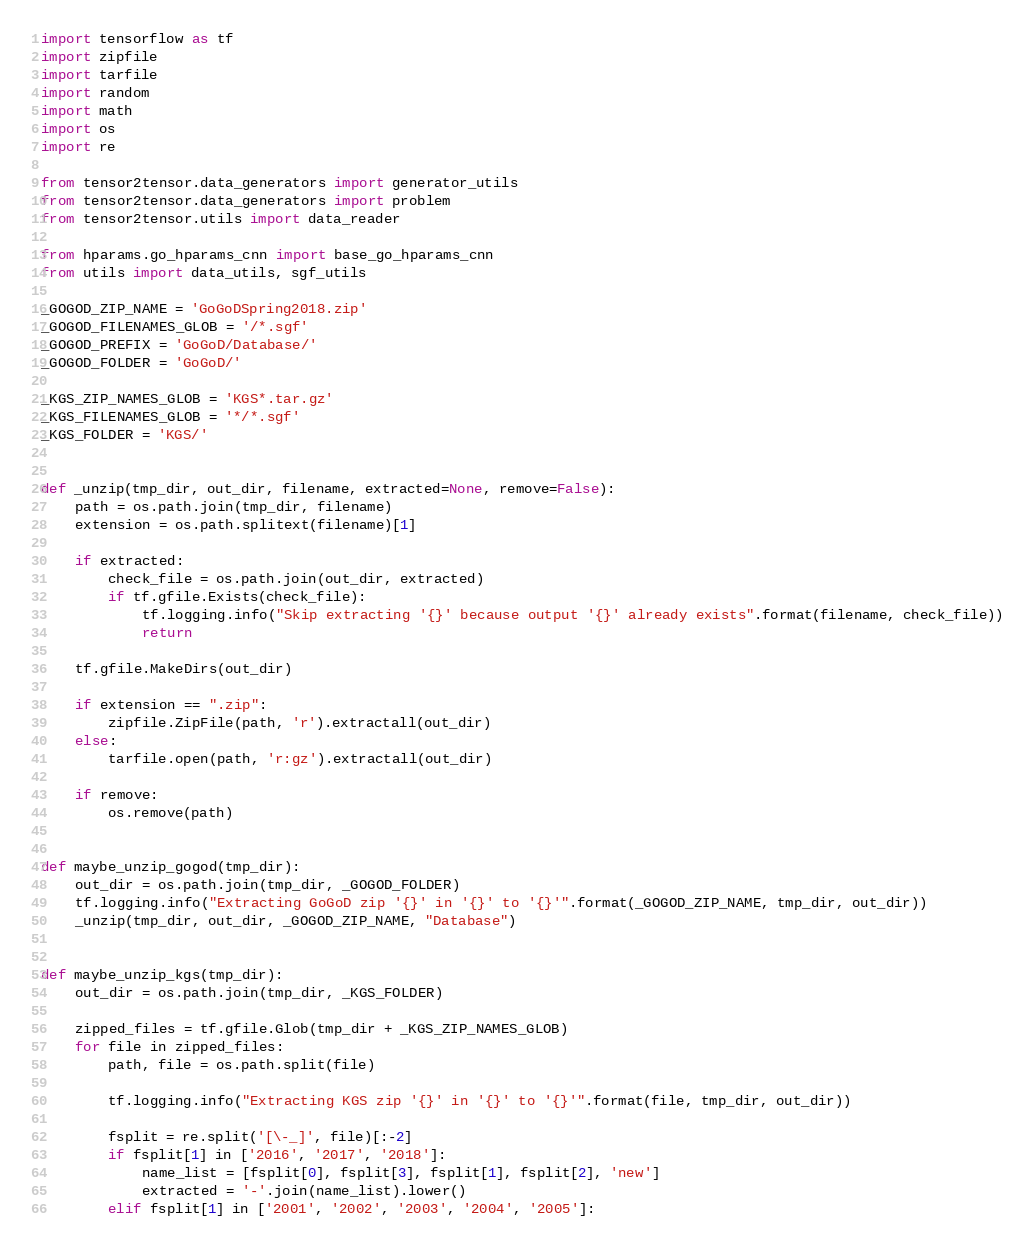Convert code to text. <code><loc_0><loc_0><loc_500><loc_500><_Python_>import tensorflow as tf
import zipfile
import tarfile
import random
import math
import os
import re

from tensor2tensor.data_generators import generator_utils
from tensor2tensor.data_generators import problem
from tensor2tensor.utils import data_reader

from hparams.go_hparams_cnn import base_go_hparams_cnn
from utils import data_utils, sgf_utils

_GOGOD_ZIP_NAME = 'GoGoDSpring2018.zip'
_GOGOD_FILENAMES_GLOB = '/*.sgf'
_GOGOD_PREFIX = 'GoGoD/Database/'
_GOGOD_FOLDER = 'GoGoD/'

_KGS_ZIP_NAMES_GLOB = 'KGS*.tar.gz'
_KGS_FILENAMES_GLOB = '*/*.sgf'
_KGS_FOLDER = 'KGS/'


def _unzip(tmp_dir, out_dir, filename, extracted=None, remove=False):
    path = os.path.join(tmp_dir, filename)
    extension = os.path.splitext(filename)[1]

    if extracted:
        check_file = os.path.join(out_dir, extracted)
        if tf.gfile.Exists(check_file):
            tf.logging.info("Skip extracting '{}' because output '{}' already exists".format(filename, check_file))
            return

    tf.gfile.MakeDirs(out_dir)

    if extension == ".zip":
        zipfile.ZipFile(path, 'r').extractall(out_dir)
    else:
        tarfile.open(path, 'r:gz').extractall(out_dir)

    if remove:
        os.remove(path)


def maybe_unzip_gogod(tmp_dir):
    out_dir = os.path.join(tmp_dir, _GOGOD_FOLDER)
    tf.logging.info("Extracting GoGoD zip '{}' in '{}' to '{}'".format(_GOGOD_ZIP_NAME, tmp_dir, out_dir))
    _unzip(tmp_dir, out_dir, _GOGOD_ZIP_NAME, "Database")


def maybe_unzip_kgs(tmp_dir):
    out_dir = os.path.join(tmp_dir, _KGS_FOLDER)

    zipped_files = tf.gfile.Glob(tmp_dir + _KGS_ZIP_NAMES_GLOB)
    for file in zipped_files:
        path, file = os.path.split(file)

        tf.logging.info("Extracting KGS zip '{}' in '{}' to '{}'".format(file, tmp_dir, out_dir))

        fsplit = re.split('[\-_]', file)[:-2]
        if fsplit[1] in ['2016', '2017', '2018']:
            name_list = [fsplit[0], fsplit[3], fsplit[1], fsplit[2], 'new']
            extracted = '-'.join(name_list).lower()
        elif fsplit[1] in ['2001', '2002', '2003', '2004', '2005']:</code> 